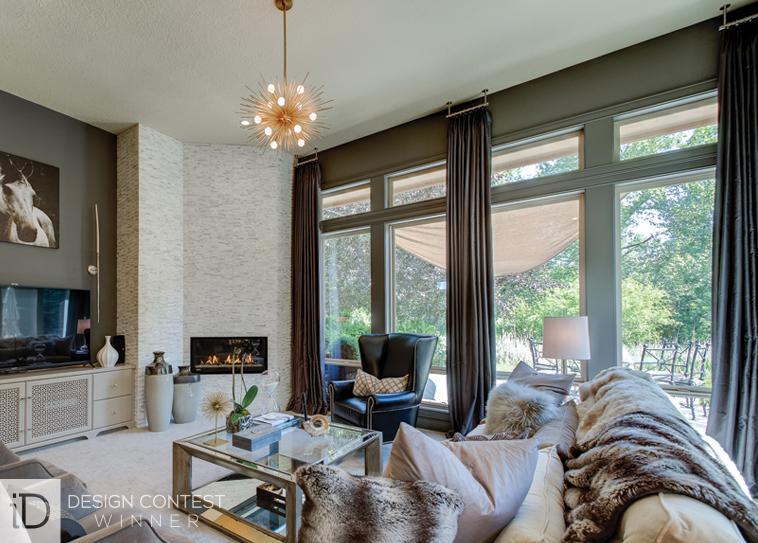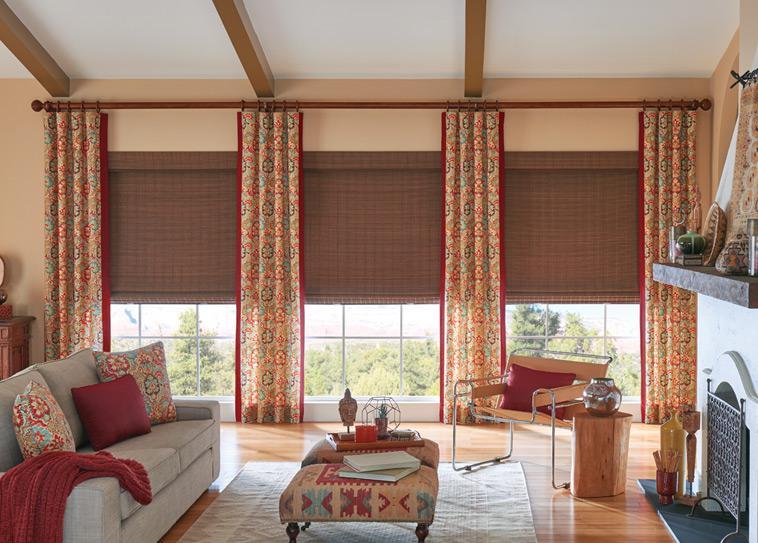The first image is the image on the left, the second image is the image on the right. Examine the images to the left and right. Is the description "The right image contains two windows with gray curtains." accurate? Answer yes or no. No. 